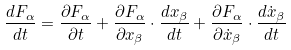Convert formula to latex. <formula><loc_0><loc_0><loc_500><loc_500>\frac { d F _ { \alpha } } { d t } = \frac { \partial F _ { \alpha } } { \partial t } + \frac { \partial F _ { \alpha } } { \partial x _ { \beta } } \cdot \frac { d x _ { \beta } } { d t } + \frac { \partial F _ { \alpha } } { \partial \dot { x } _ { \beta } } \cdot \frac { d \dot { x } _ { \beta } } { d t }</formula> 